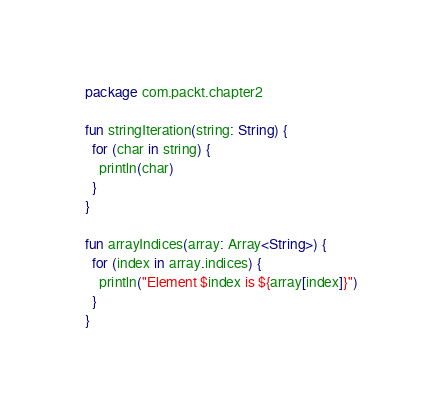Convert code to text. <code><loc_0><loc_0><loc_500><loc_500><_Kotlin_>package com.packt.chapter2

fun stringIteration(string: String) {
  for (char in string) {
    println(char)
  }
}

fun arrayIndices(array: Array<String>) {
  for (index in array.indices) {
    println("Element $index is ${array[index]}")
  }
}</code> 